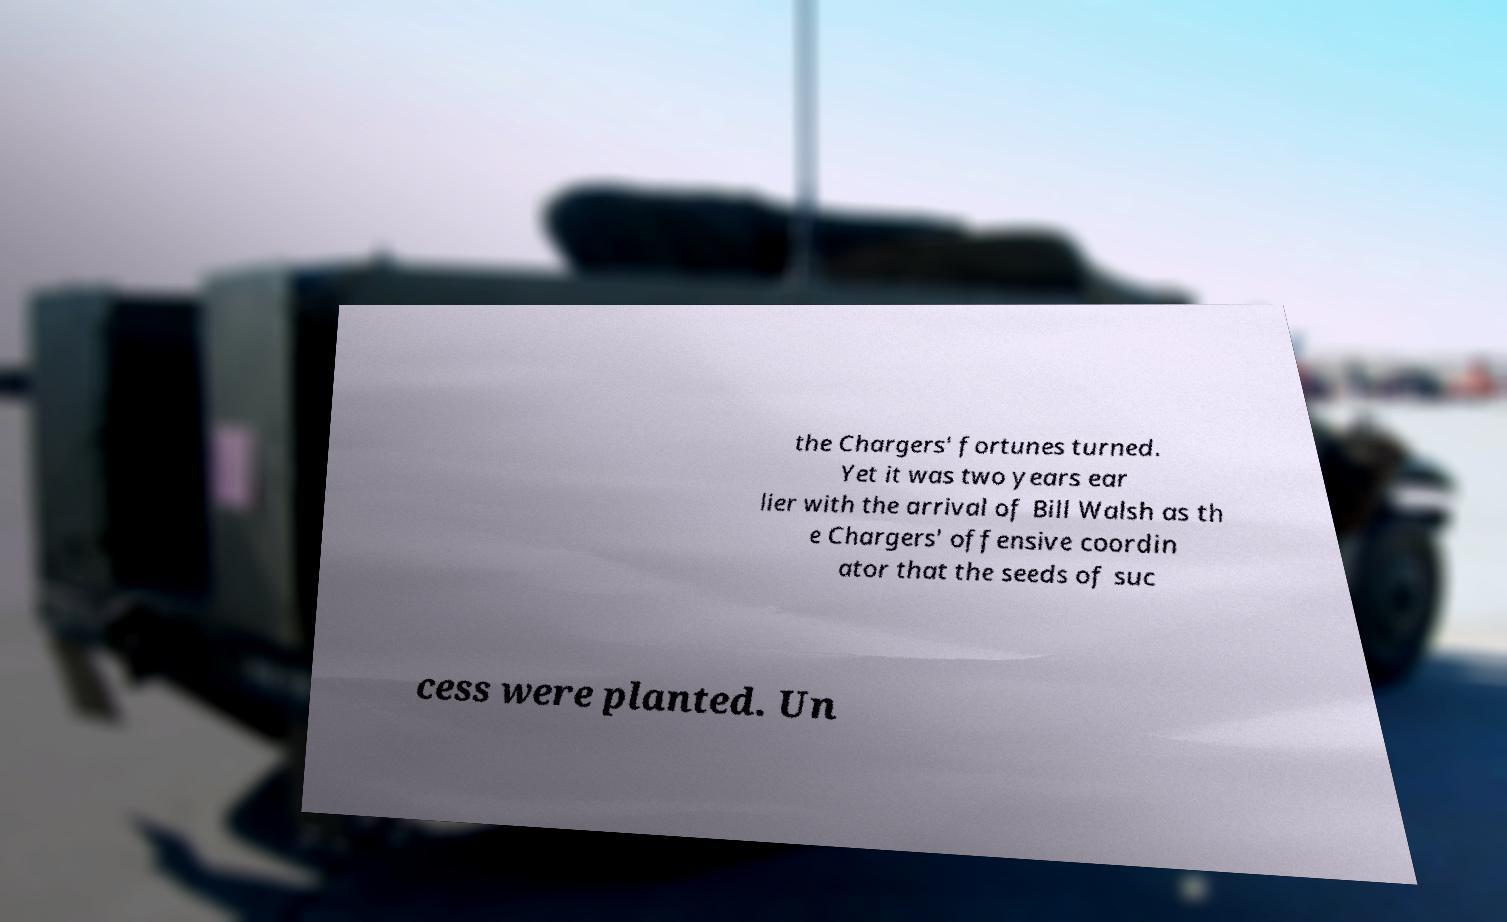I need the written content from this picture converted into text. Can you do that? the Chargers' fortunes turned. Yet it was two years ear lier with the arrival of Bill Walsh as th e Chargers' offensive coordin ator that the seeds of suc cess were planted. Un 